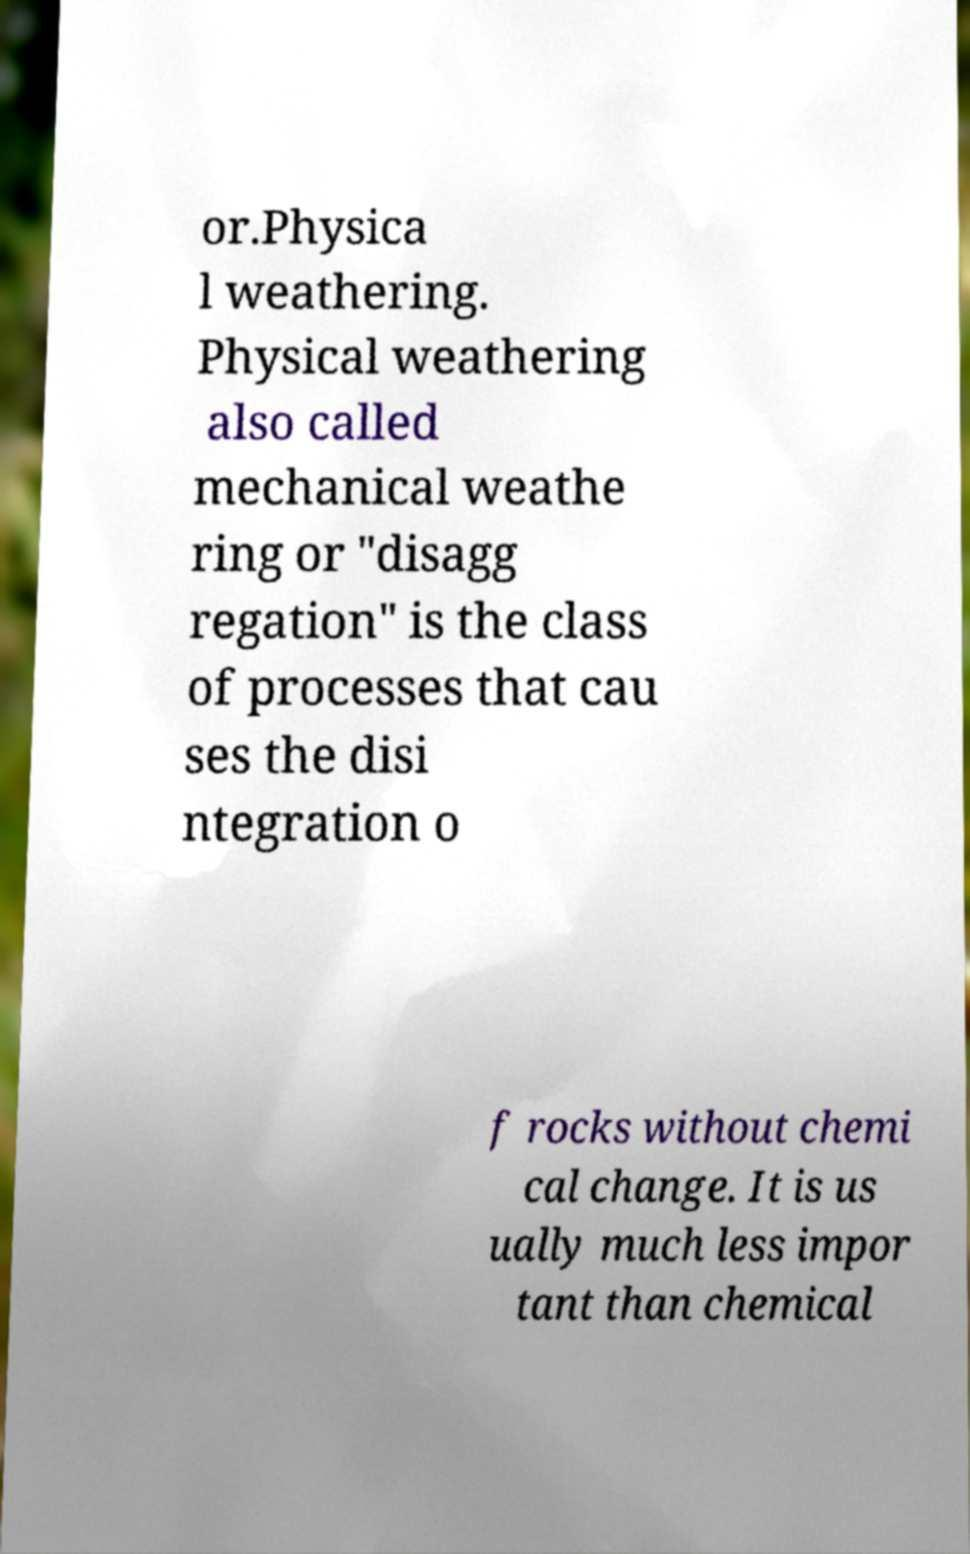There's text embedded in this image that I need extracted. Can you transcribe it verbatim? or.Physica l weathering. Physical weathering also called mechanical weathe ring or "disagg regation" is the class of processes that cau ses the disi ntegration o f rocks without chemi cal change. It is us ually much less impor tant than chemical 